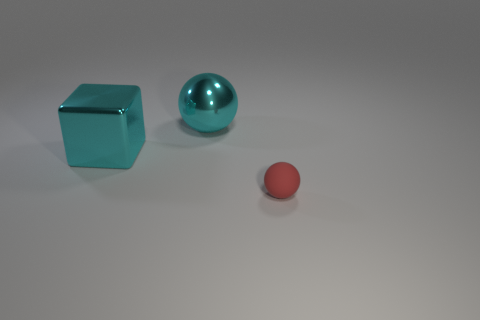Does the large object that is behind the cube have the same shape as the small rubber object?
Make the answer very short. Yes. Is there anything else that has the same material as the red object?
Your answer should be compact. No. Is the sphere behind the cyan metallic block made of the same material as the tiny red object?
Provide a short and direct response. No. What material is the object behind the cyan thing in front of the ball that is left of the red thing made of?
Your answer should be very brief. Metal. There is a metallic thing on the left side of the cyan sphere; what is its color?
Your answer should be very brief. Cyan. There is a large cyan shiny thing to the left of the large object that is behind the large shiny cube; what number of metal spheres are in front of it?
Offer a terse response. 0. There is a big thing that is left of the big ball; what number of red things are in front of it?
Your answer should be compact. 1. What number of big metal cubes are on the right side of the shiny sphere?
Your response must be concise. 0. How many other objects are there of the same size as the cyan shiny sphere?
Your answer should be very brief. 1. What is the size of the cyan thing that is the same shape as the small red object?
Your response must be concise. Large. 